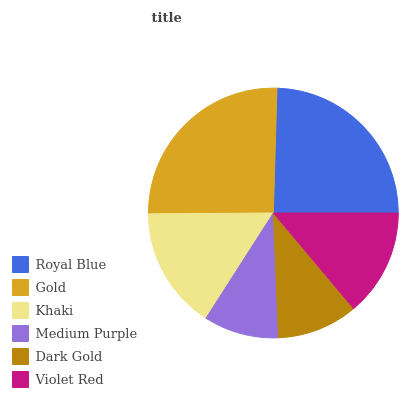Is Medium Purple the minimum?
Answer yes or no. Yes. Is Gold the maximum?
Answer yes or no. Yes. Is Khaki the minimum?
Answer yes or no. No. Is Khaki the maximum?
Answer yes or no. No. Is Gold greater than Khaki?
Answer yes or no. Yes. Is Khaki less than Gold?
Answer yes or no. Yes. Is Khaki greater than Gold?
Answer yes or no. No. Is Gold less than Khaki?
Answer yes or no. No. Is Khaki the high median?
Answer yes or no. Yes. Is Violet Red the low median?
Answer yes or no. Yes. Is Royal Blue the high median?
Answer yes or no. No. Is Medium Purple the low median?
Answer yes or no. No. 